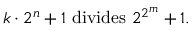<formula> <loc_0><loc_0><loc_500><loc_500>k \cdot 2 ^ { n } + 1 { d i v i d e s } 2 ^ { 2 ^ { m } } + 1 .</formula> 